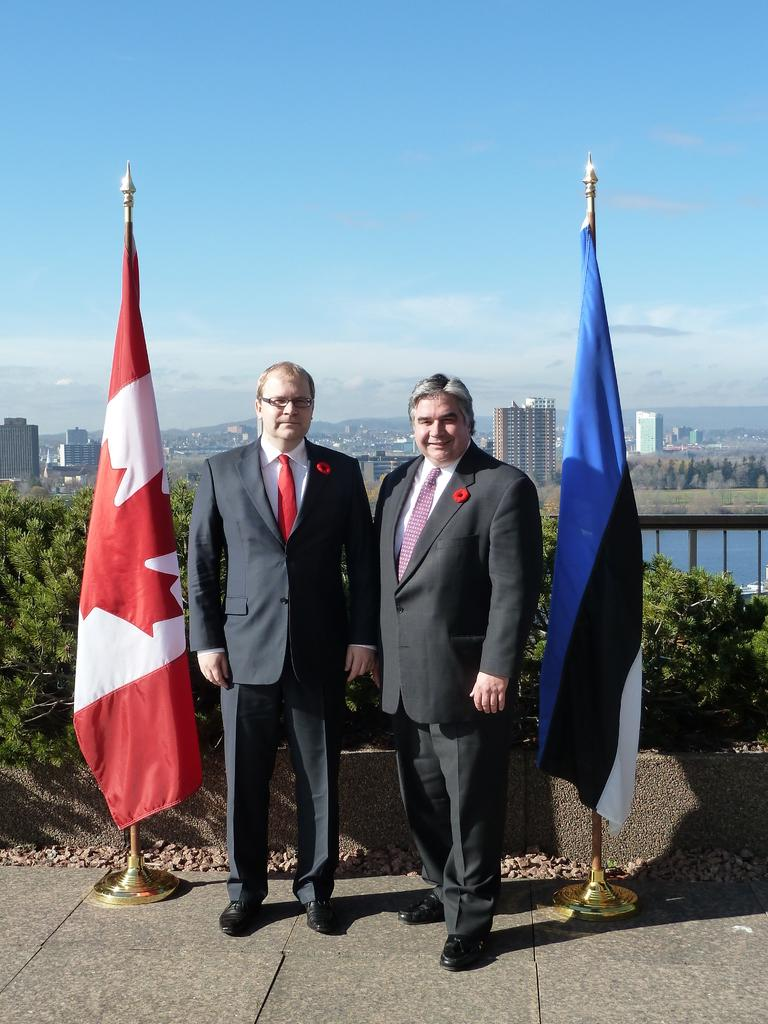How many people are present in the image? There are two men standing in the image. What can be seen in the image besides the men? There are flags, plants, a fence, water, trees, buildings, and the sky visible in the image. What type of structures are present in the image? There are buildings in the image. What natural elements can be seen in the image? There are plants, water, trees, and the sky visible in the image. What type of apparel is being used to measure the range of the cord in the image? There is no apparel, range, or cord present in the image. 